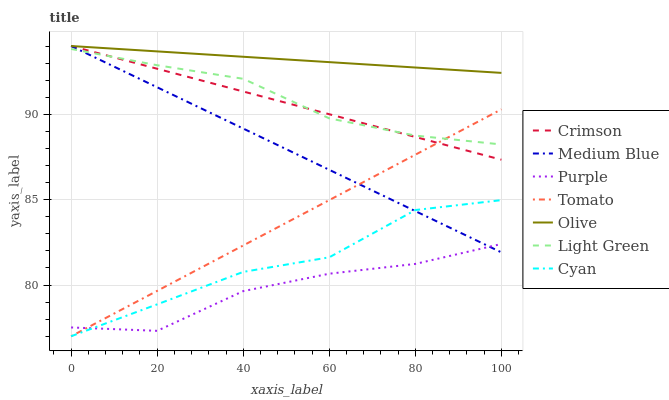Does Purple have the minimum area under the curve?
Answer yes or no. Yes. Does Olive have the maximum area under the curve?
Answer yes or no. Yes. Does Medium Blue have the minimum area under the curve?
Answer yes or no. No. Does Medium Blue have the maximum area under the curve?
Answer yes or no. No. Is Tomato the smoothest?
Answer yes or no. Yes. Is Cyan the roughest?
Answer yes or no. Yes. Is Purple the smoothest?
Answer yes or no. No. Is Purple the roughest?
Answer yes or no. No. Does Tomato have the lowest value?
Answer yes or no. Yes. Does Purple have the lowest value?
Answer yes or no. No. Does Crimson have the highest value?
Answer yes or no. Yes. Does Purple have the highest value?
Answer yes or no. No. Is Tomato less than Olive?
Answer yes or no. Yes. Is Light Green greater than Cyan?
Answer yes or no. Yes. Does Crimson intersect Olive?
Answer yes or no. Yes. Is Crimson less than Olive?
Answer yes or no. No. Is Crimson greater than Olive?
Answer yes or no. No. Does Tomato intersect Olive?
Answer yes or no. No. 